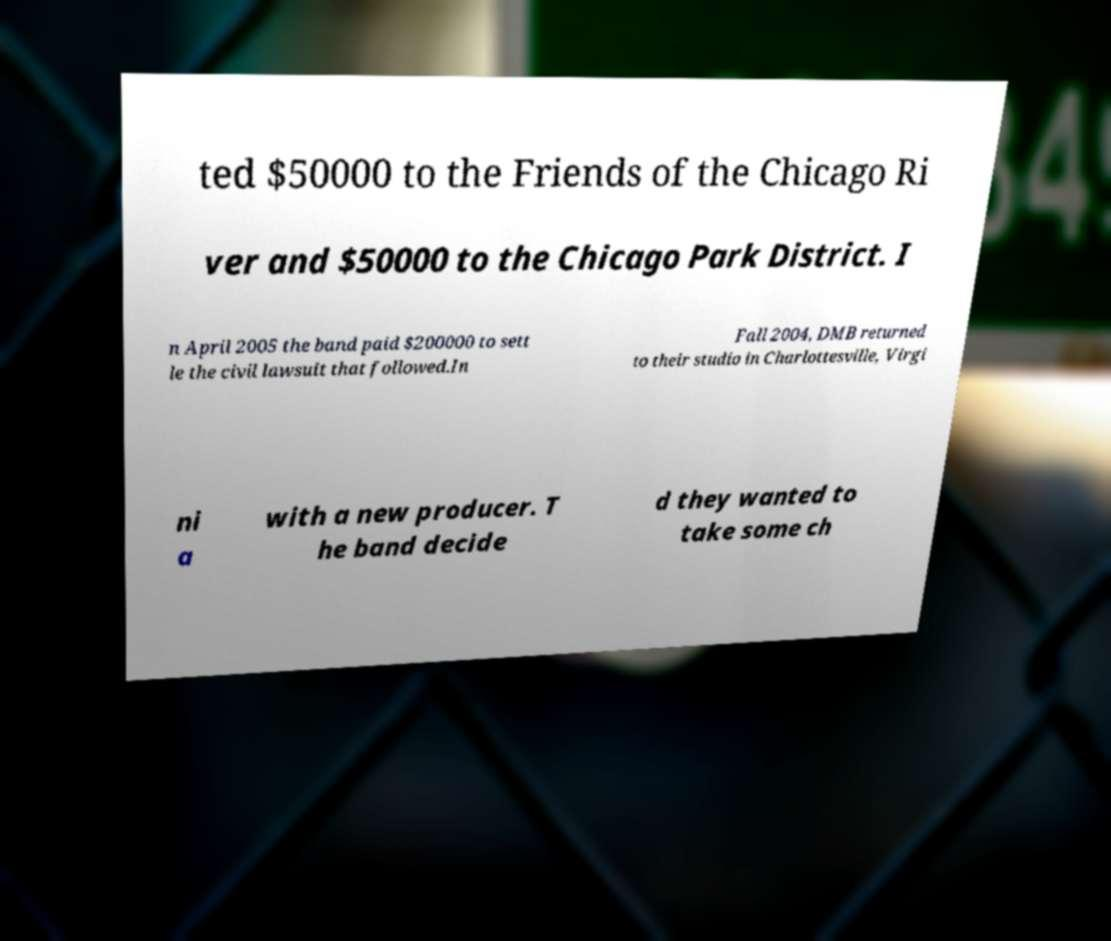Please identify and transcribe the text found in this image. ted $50000 to the Friends of the Chicago Ri ver and $50000 to the Chicago Park District. I n April 2005 the band paid $200000 to sett le the civil lawsuit that followed.In Fall 2004, DMB returned to their studio in Charlottesville, Virgi ni a with a new producer. T he band decide d they wanted to take some ch 